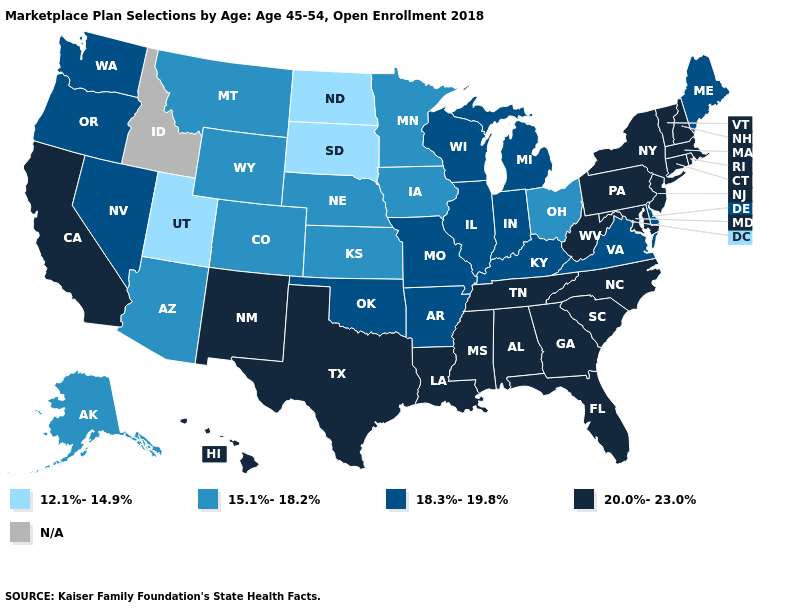Does Missouri have the lowest value in the MidWest?
Keep it brief. No. What is the value of Wisconsin?
Keep it brief. 18.3%-19.8%. Among the states that border New Jersey , does Delaware have the highest value?
Write a very short answer. No. What is the value of Ohio?
Keep it brief. 15.1%-18.2%. What is the value of Kentucky?
Answer briefly. 18.3%-19.8%. What is the highest value in the West ?
Short answer required. 20.0%-23.0%. Does Colorado have the highest value in the West?
Give a very brief answer. No. What is the value of Idaho?
Keep it brief. N/A. What is the lowest value in states that border Maryland?
Quick response, please. 18.3%-19.8%. What is the value of Tennessee?
Quick response, please. 20.0%-23.0%. Name the states that have a value in the range 12.1%-14.9%?
Give a very brief answer. North Dakota, South Dakota, Utah. How many symbols are there in the legend?
Quick response, please. 5. What is the lowest value in states that border Massachusetts?
Give a very brief answer. 20.0%-23.0%. What is the value of North Carolina?
Keep it brief. 20.0%-23.0%. 